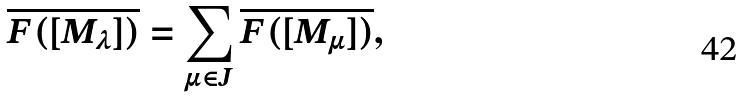<formula> <loc_0><loc_0><loc_500><loc_500>\overline { F ( [ M _ { \lambda } ] ) } = \sum _ { \mu \in J } \overline { F ( [ M _ { \mu } ] ) } ,</formula> 